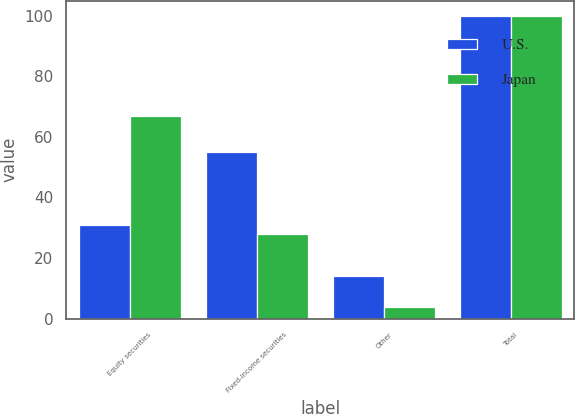Convert chart. <chart><loc_0><loc_0><loc_500><loc_500><stacked_bar_chart><ecel><fcel>Equity securities<fcel>Fixed-income securities<fcel>Other<fcel>Total<nl><fcel>U.S.<fcel>31<fcel>55<fcel>14<fcel>100<nl><fcel>Japan<fcel>67<fcel>28<fcel>4<fcel>100<nl></chart> 